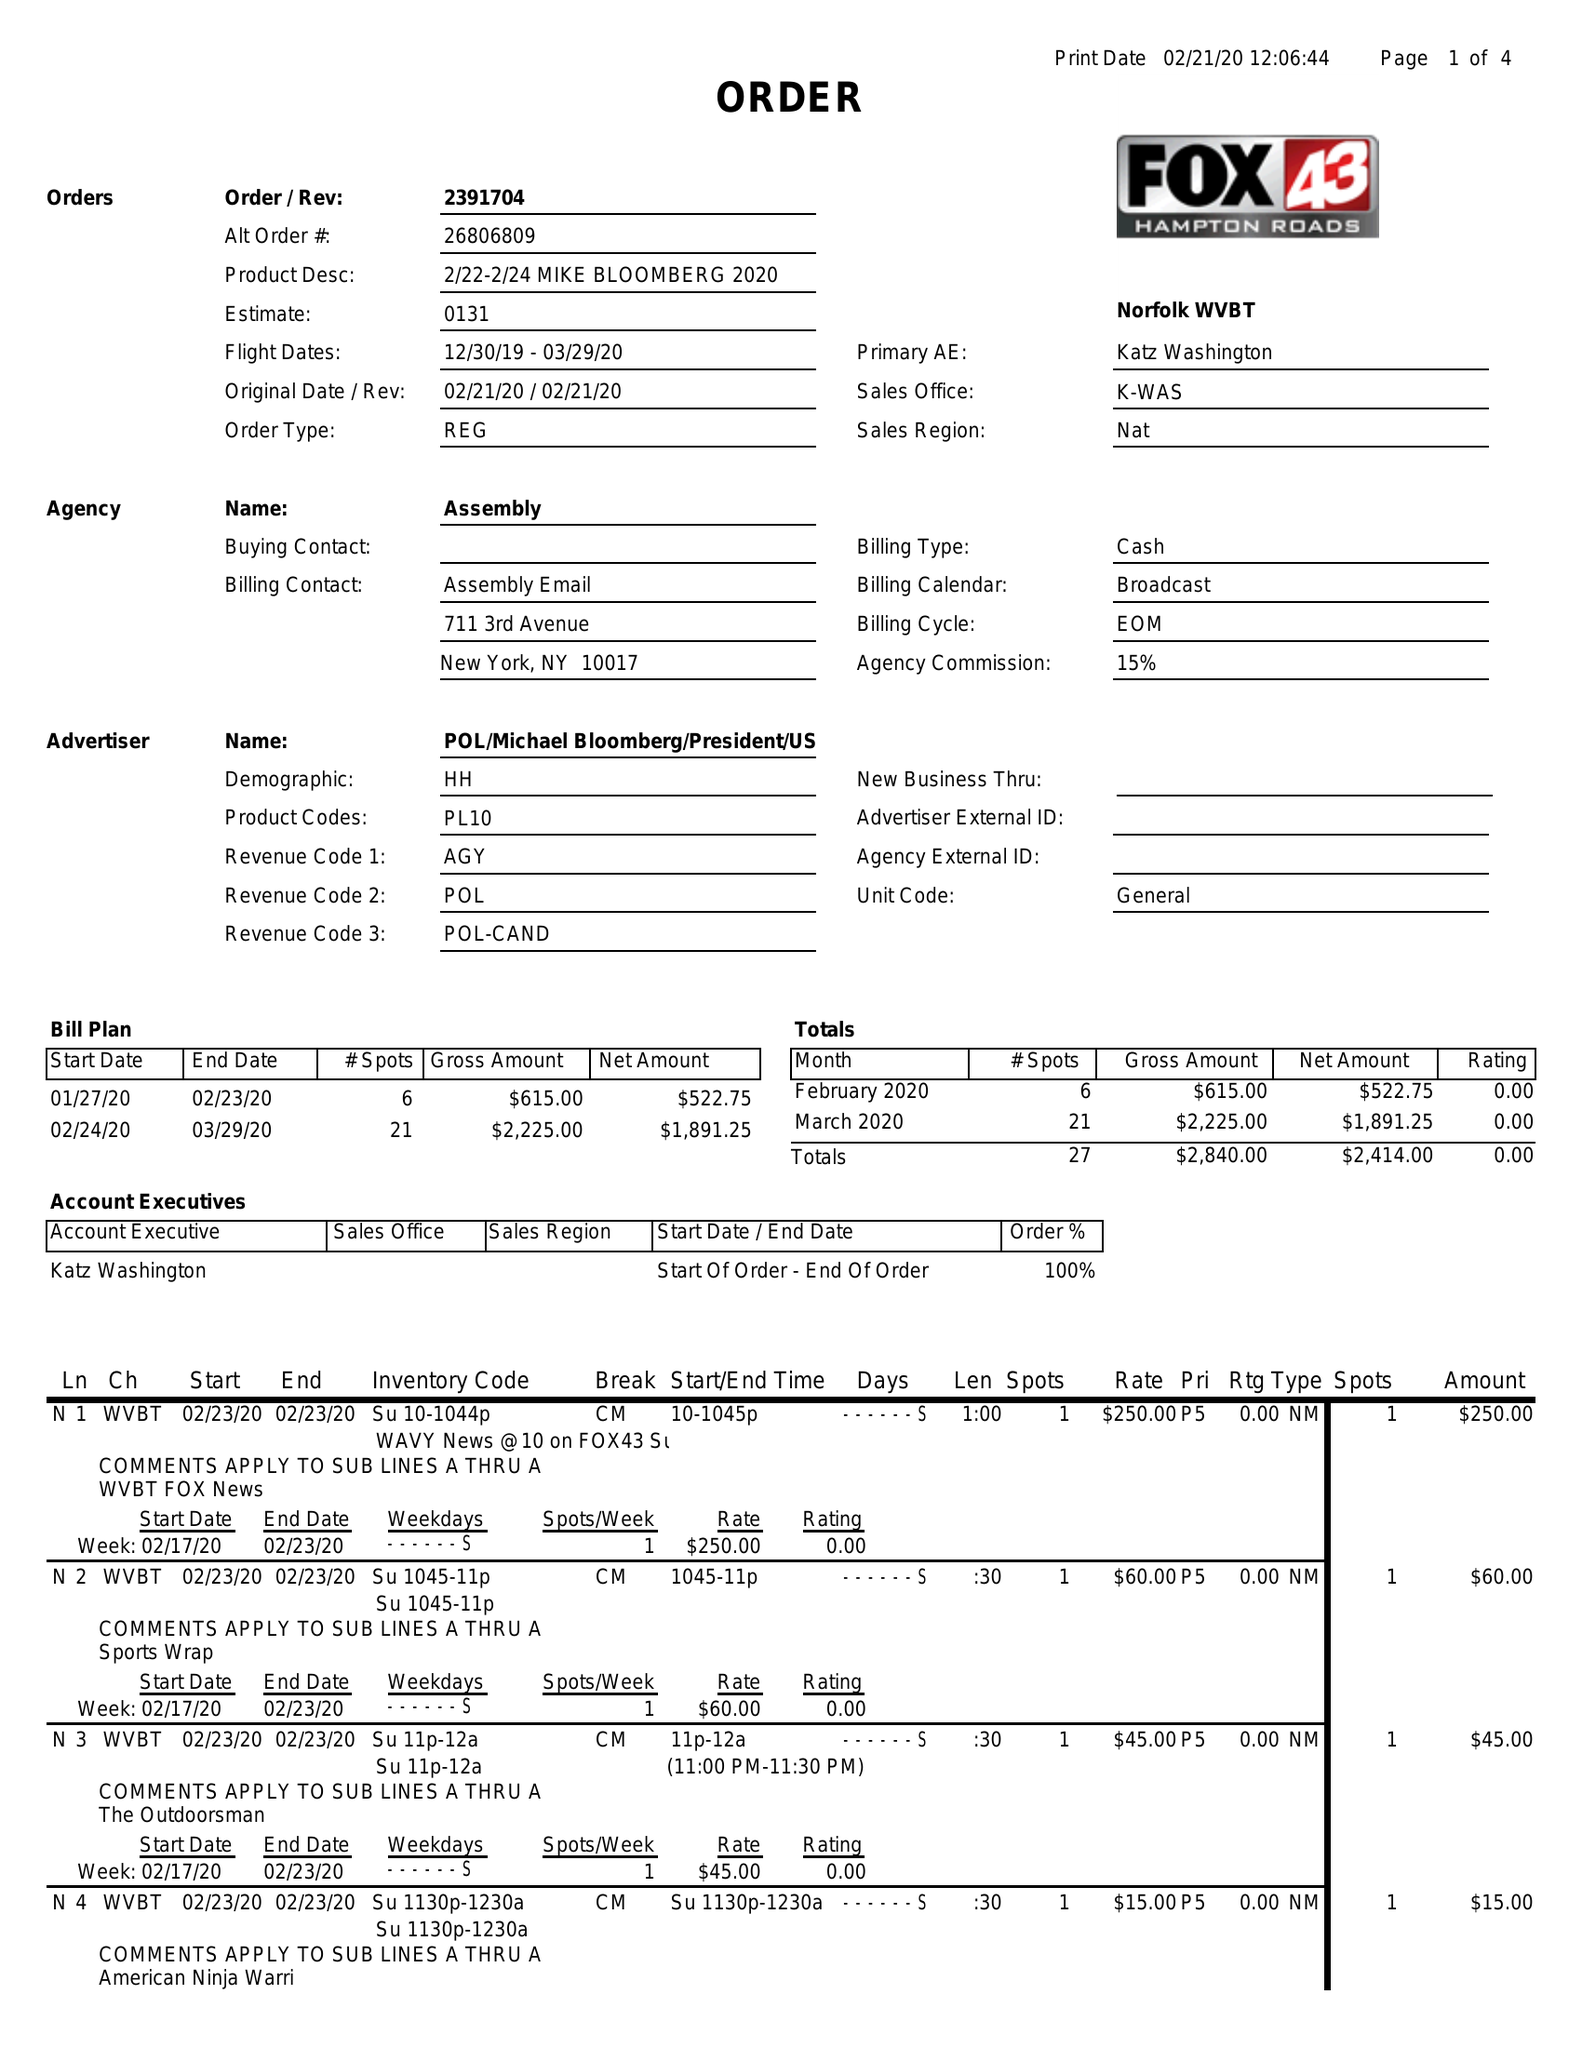What is the value for the flight_to?
Answer the question using a single word or phrase. 03/29/20 